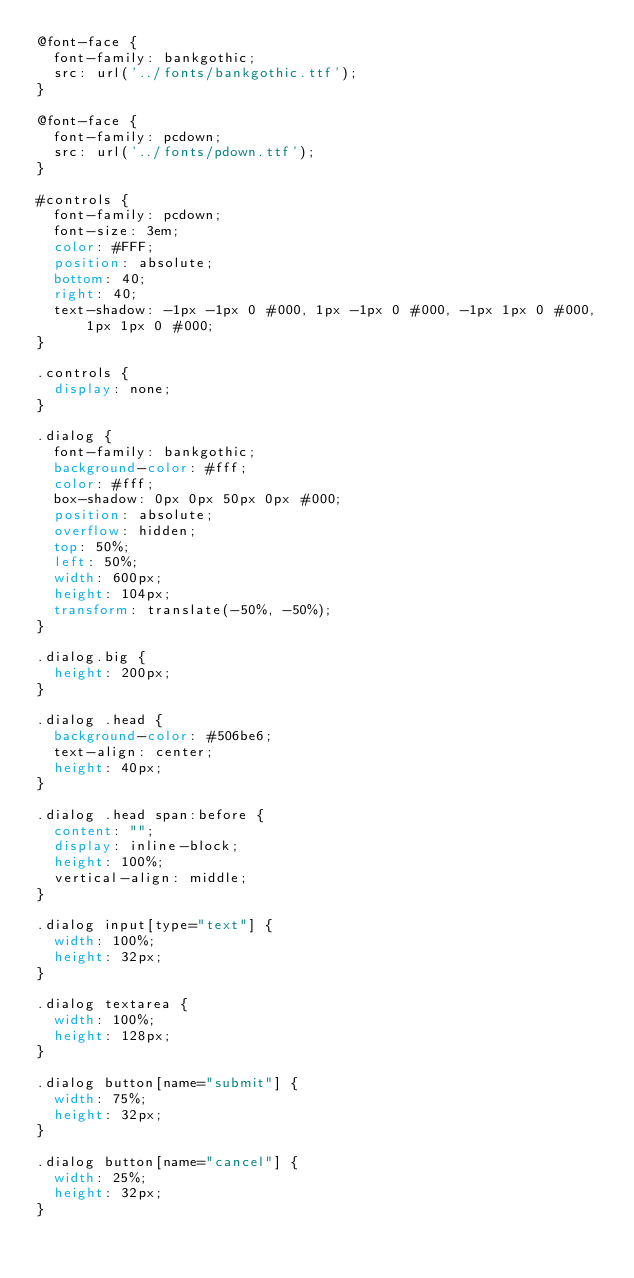<code> <loc_0><loc_0><loc_500><loc_500><_CSS_>@font-face {
	font-family: bankgothic;
	src: url('../fonts/bankgothic.ttf');
}

@font-face {
	font-family: pcdown;
	src: url('../fonts/pdown.ttf');
}

#controls {
	font-family: pcdown;
	font-size: 3em;
	color: #FFF;
	position: absolute;
	bottom: 40;
	right: 40;
	text-shadow: -1px -1px 0 #000, 1px -1px 0 #000, -1px 1px 0 #000, 1px 1px 0 #000;
}

.controls {
	display: none;
}

.dialog {
	font-family: bankgothic;
	background-color: #fff;
	color: #fff;
	box-shadow: 0px 0px 50px 0px #000;
	position: absolute;
	overflow: hidden;
	top: 50%;
	left: 50%;
	width: 600px;
	height: 104px;
	transform: translate(-50%, -50%);
}

.dialog.big {
	height: 200px;
}

.dialog .head {
	background-color: #506be6;
	text-align: center;
	height: 40px;
}

.dialog .head span:before {
	content: "";
	display: inline-block;
	height: 100%;
	vertical-align: middle;
}

.dialog input[type="text"] {
	width: 100%;
	height: 32px;
}

.dialog textarea {
	width: 100%;
	height: 128px;
}

.dialog button[name="submit"] {
	width: 75%;
	height: 32px;
}

.dialog button[name="cancel"] {
	width: 25%;
	height: 32px;
}
</code> 